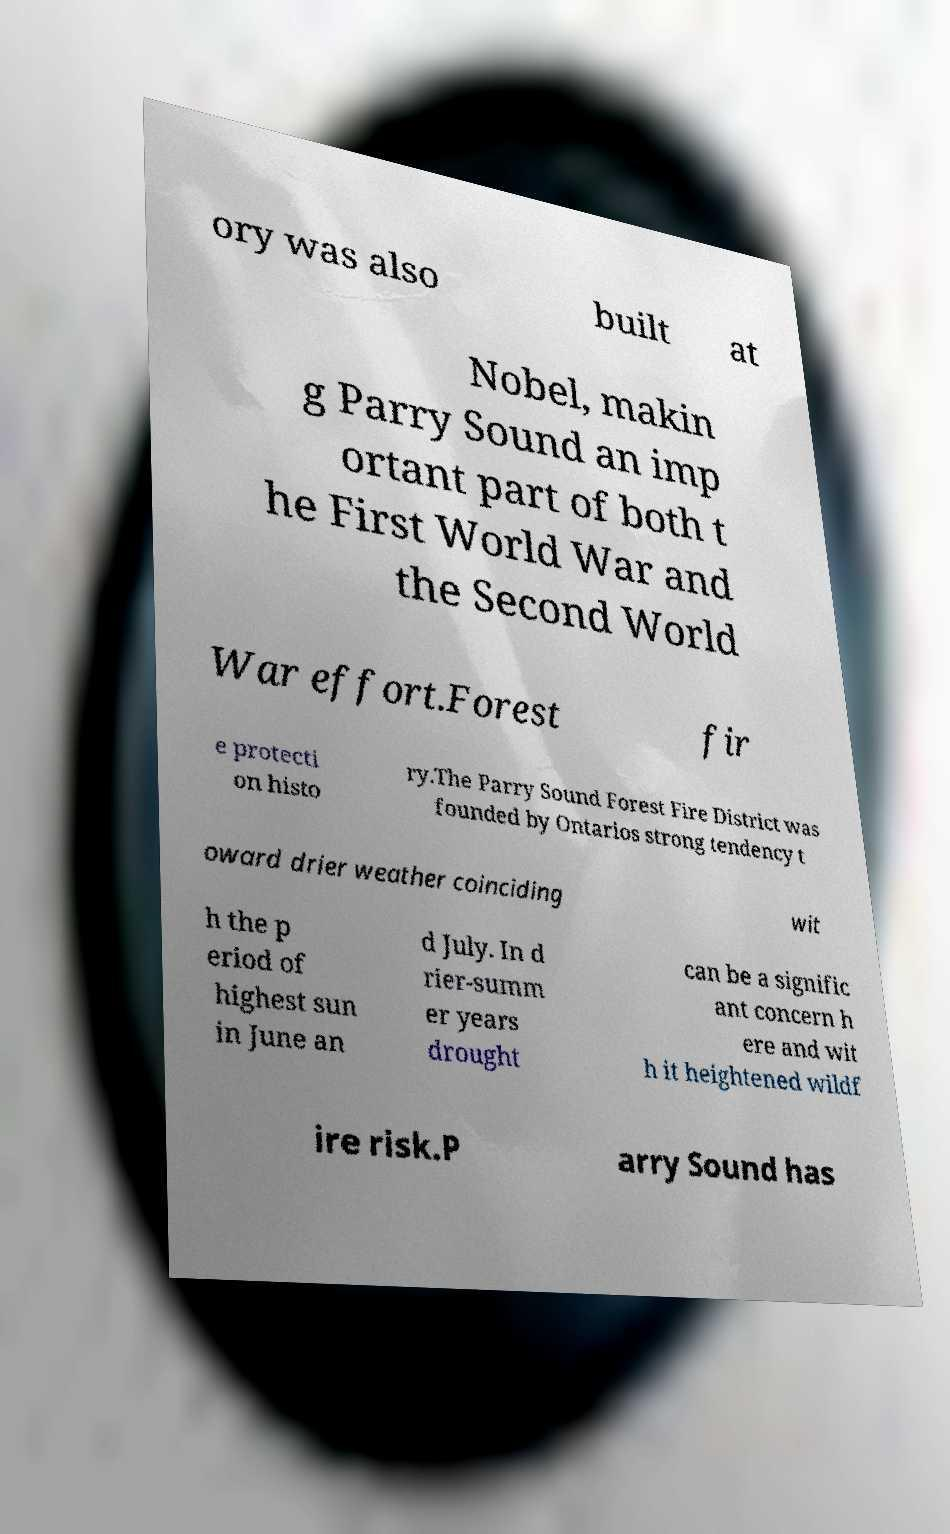Can you read and provide the text displayed in the image?This photo seems to have some interesting text. Can you extract and type it out for me? ory was also built at Nobel, makin g Parry Sound an imp ortant part of both t he First World War and the Second World War effort.Forest fir e protecti on histo ry.The Parry Sound Forest Fire District was founded by Ontarios strong tendency t oward drier weather coinciding wit h the p eriod of highest sun in June an d July. In d rier-summ er years drought can be a signific ant concern h ere and wit h it heightened wildf ire risk.P arry Sound has 